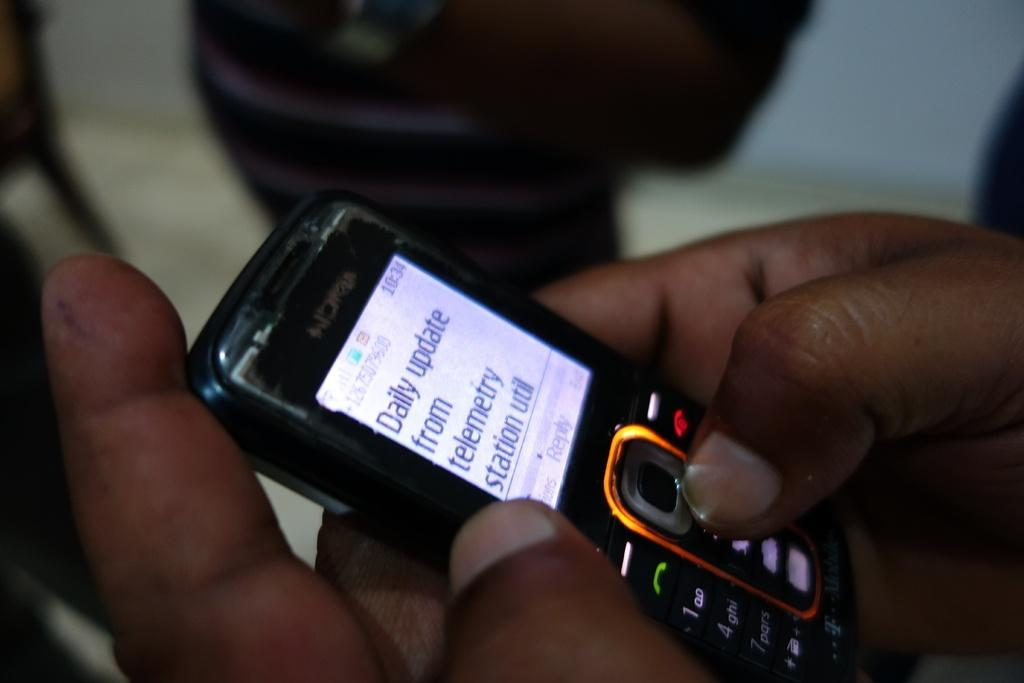<image>
Offer a succinct explanation of the picture presented. A person using a Nokia phone to find the daily update from telemetry station utilities. 